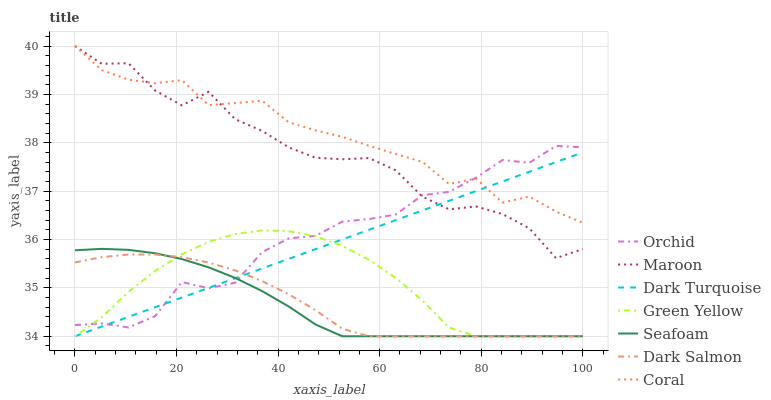Does Seafoam have the minimum area under the curve?
Answer yes or no. Yes. Does Coral have the maximum area under the curve?
Answer yes or no. Yes. Does Dark Salmon have the minimum area under the curve?
Answer yes or no. No. Does Dark Salmon have the maximum area under the curve?
Answer yes or no. No. Is Dark Turquoise the smoothest?
Answer yes or no. Yes. Is Maroon the roughest?
Answer yes or no. Yes. Is Coral the smoothest?
Answer yes or no. No. Is Coral the roughest?
Answer yes or no. No. Does Dark Turquoise have the lowest value?
Answer yes or no. Yes. Does Coral have the lowest value?
Answer yes or no. No. Does Maroon have the highest value?
Answer yes or no. Yes. Does Dark Salmon have the highest value?
Answer yes or no. No. Is Seafoam less than Coral?
Answer yes or no. Yes. Is Maroon greater than Green Yellow?
Answer yes or no. Yes. Does Green Yellow intersect Seafoam?
Answer yes or no. Yes. Is Green Yellow less than Seafoam?
Answer yes or no. No. Is Green Yellow greater than Seafoam?
Answer yes or no. No. Does Seafoam intersect Coral?
Answer yes or no. No. 